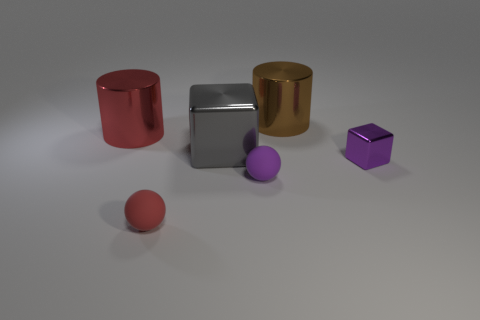Add 2 large blocks. How many objects exist? 8 Subtract all gray blocks. How many blocks are left? 1 Subtract all spheres. How many objects are left? 4 Subtract all red cylinders. How many gray cubes are left? 1 Subtract 1 cubes. How many cubes are left? 1 Subtract all yellow cylinders. Subtract all cyan cubes. How many cylinders are left? 2 Subtract all small matte objects. Subtract all large brown metallic cylinders. How many objects are left? 3 Add 4 big metallic things. How many big metallic things are left? 7 Add 4 large brown cylinders. How many large brown cylinders exist? 5 Subtract 1 gray cubes. How many objects are left? 5 